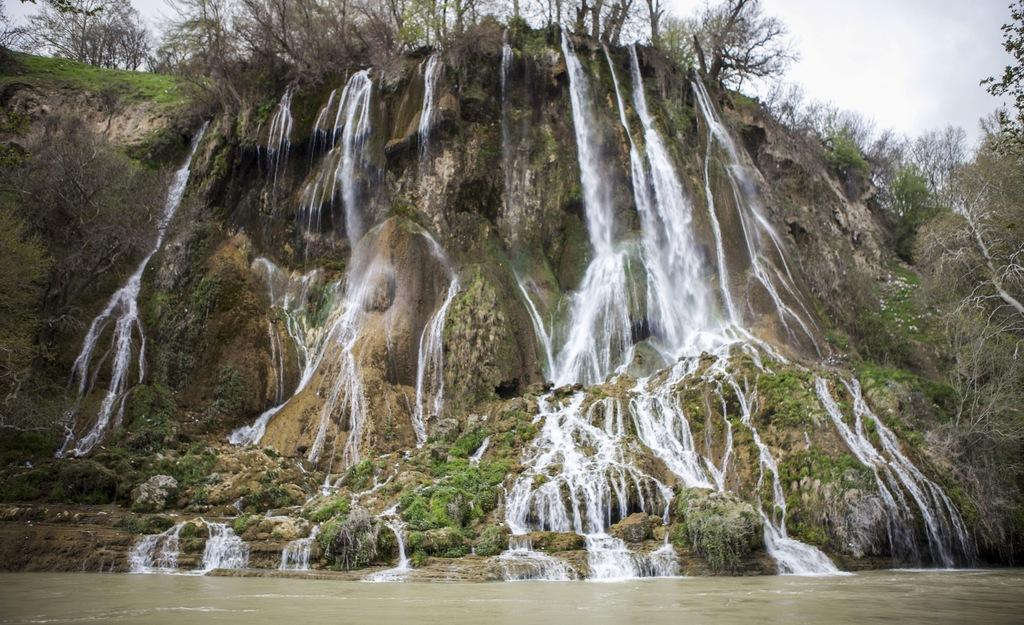What natural feature is the main subject of the image? There is a waterfall in the image. What is the result of the waterfall in the image? Water is present at the bottom of the waterfall. What type of vegetation can be seen in the front of the image? Small plants and grass are visible in the front of the image. What is visible at the top of the image? There are trees at the top of the image, and the sky is also visible. Can you tell me how many clocks are hanging from the trees in the image? There are no clocks present in the image; it features a waterfall, water, vegetation, and trees. What type of game is being played by the stranger in the image? There is no stranger or game being played in the image; it focuses on the waterfall and its surroundings. 